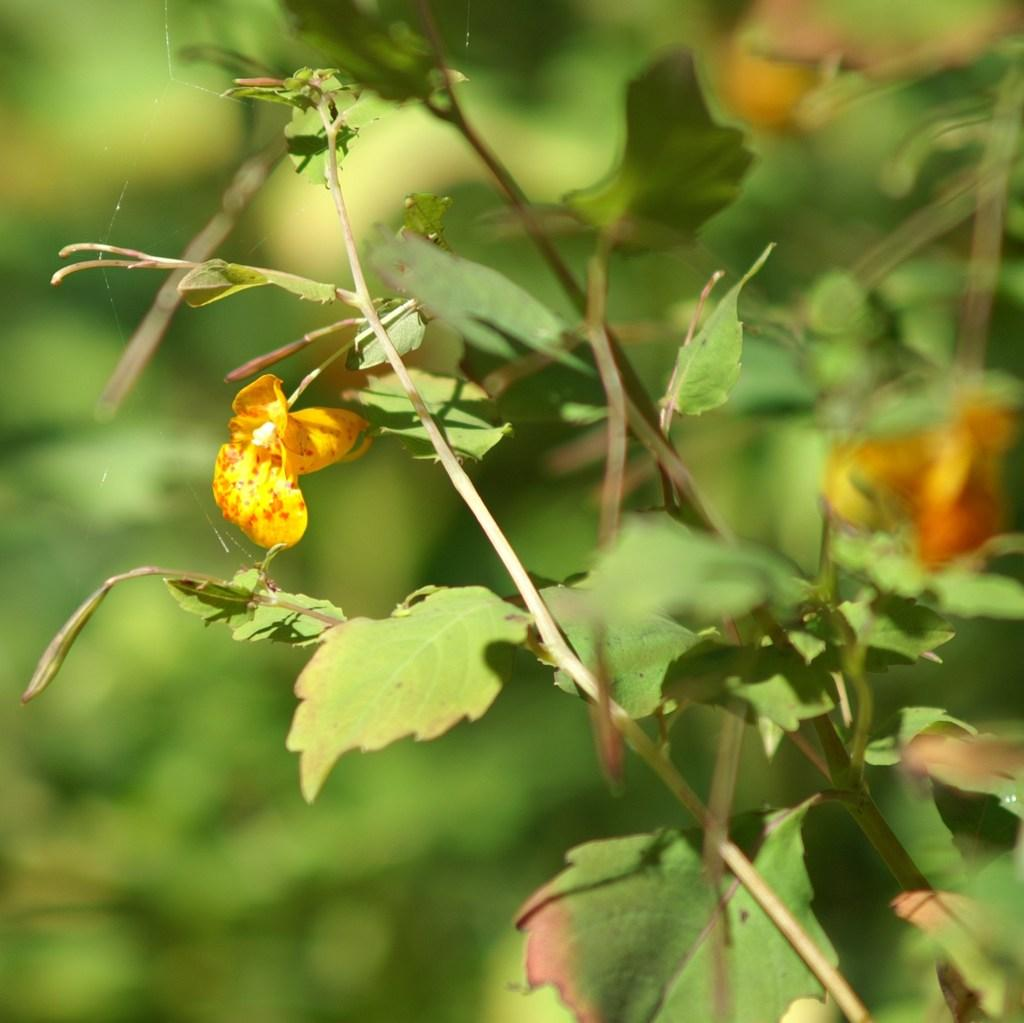What type of living organisms can be seen in the image? Flowers and plants are visible in the image. Can you describe the plants in the image? The image contains flowers, which are a type of plant. What type of mine can be seen in the image? There is no mine present in the image; it contains flowers and plants. What is inside the jar in the image? There is no jar present in the image. 